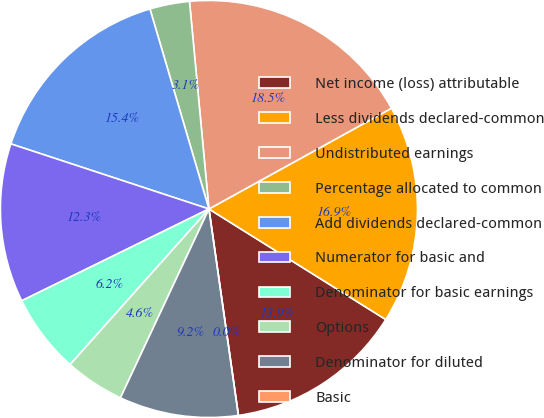<chart> <loc_0><loc_0><loc_500><loc_500><pie_chart><fcel>Net income (loss) attributable<fcel>Less dividends declared-common<fcel>Undistributed earnings<fcel>Percentage allocated to common<fcel>Add dividends declared-common<fcel>Numerator for basic and<fcel>Denominator for basic earnings<fcel>Options<fcel>Denominator for diluted<fcel>Basic<nl><fcel>13.85%<fcel>16.92%<fcel>18.46%<fcel>3.08%<fcel>15.38%<fcel>12.31%<fcel>6.15%<fcel>4.62%<fcel>9.23%<fcel>0.0%<nl></chart> 